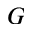Convert formula to latex. <formula><loc_0><loc_0><loc_500><loc_500>G</formula> 